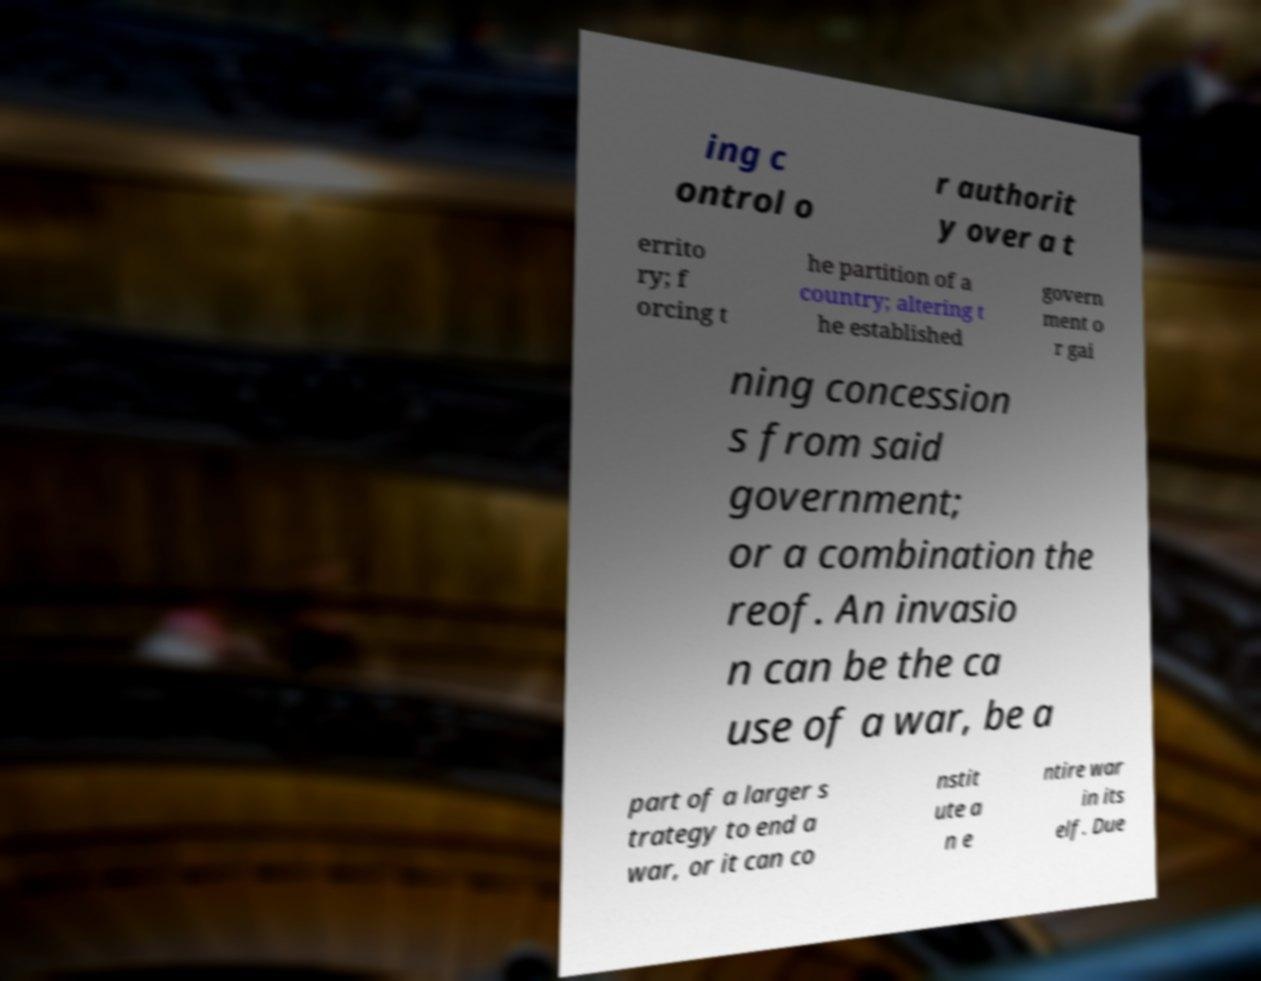There's text embedded in this image that I need extracted. Can you transcribe it verbatim? ing c ontrol o r authorit y over a t errito ry; f orcing t he partition of a country; altering t he established govern ment o r gai ning concession s from said government; or a combination the reof. An invasio n can be the ca use of a war, be a part of a larger s trategy to end a war, or it can co nstit ute a n e ntire war in its elf. Due 